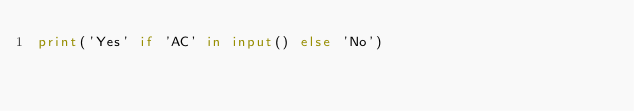<code> <loc_0><loc_0><loc_500><loc_500><_Python_>print('Yes' if 'AC' in input() else 'No')</code> 